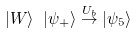<formula> <loc_0><loc_0><loc_500><loc_500>| W \rangle \ | \psi _ { + } \rangle \stackrel { U _ { b } } { \rightarrow } | \psi _ { 5 } \rangle</formula> 